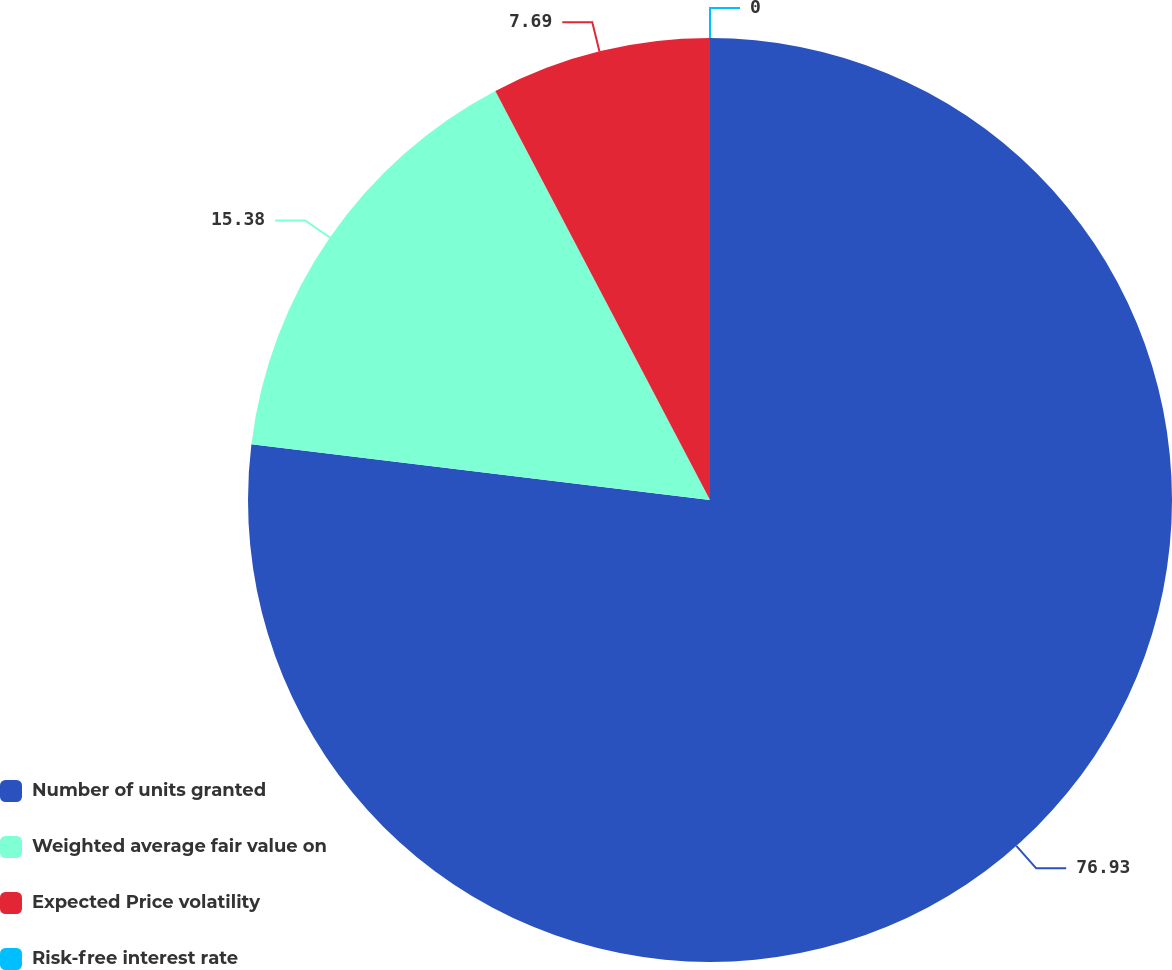Convert chart to OTSL. <chart><loc_0><loc_0><loc_500><loc_500><pie_chart><fcel>Number of units granted<fcel>Weighted average fair value on<fcel>Expected Price volatility<fcel>Risk-free interest rate<nl><fcel>76.92%<fcel>15.38%<fcel>7.69%<fcel>0.0%<nl></chart> 